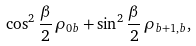Convert formula to latex. <formula><loc_0><loc_0><loc_500><loc_500>\cos ^ { 2 } \frac { \beta } { 2 } \, \rho _ { 0 b } + \sin ^ { 2 } \frac { \beta } { 2 } \, \rho _ { b + 1 , b } ,</formula> 